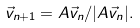<formula> <loc_0><loc_0><loc_500><loc_500>\vec { v } _ { n + 1 } = A \vec { v } _ { n } / | A \vec { v } _ { n } | .</formula> 